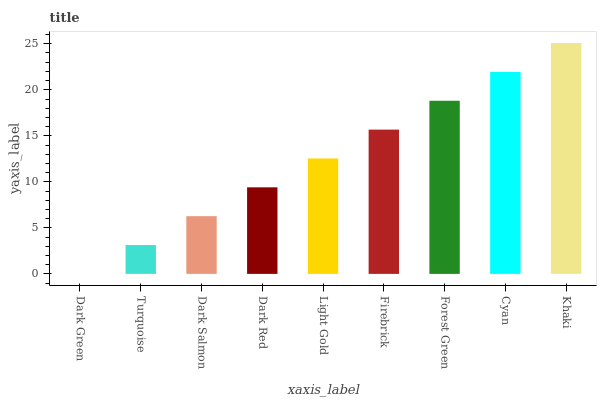Is Turquoise the minimum?
Answer yes or no. No. Is Turquoise the maximum?
Answer yes or no. No. Is Turquoise greater than Dark Green?
Answer yes or no. Yes. Is Dark Green less than Turquoise?
Answer yes or no. Yes. Is Dark Green greater than Turquoise?
Answer yes or no. No. Is Turquoise less than Dark Green?
Answer yes or no. No. Is Light Gold the high median?
Answer yes or no. Yes. Is Light Gold the low median?
Answer yes or no. Yes. Is Turquoise the high median?
Answer yes or no. No. Is Khaki the low median?
Answer yes or no. No. 